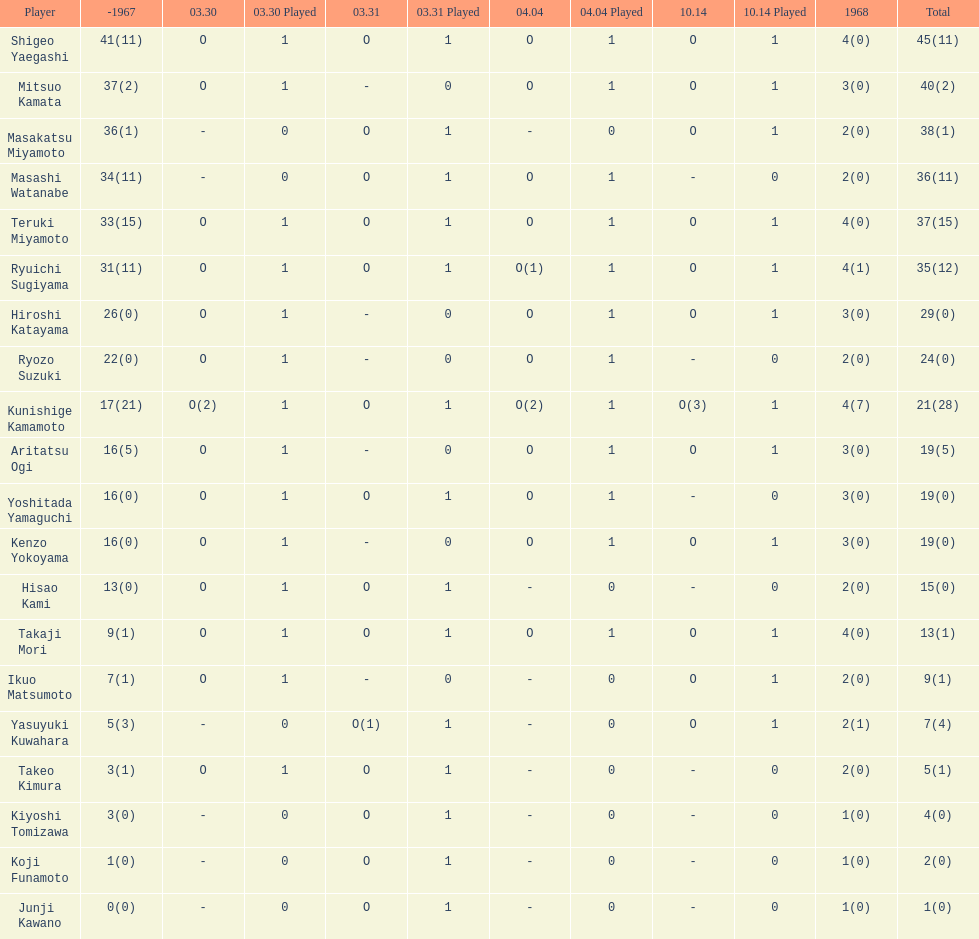Did mitsuo kamata have more than 40 total points? No. 